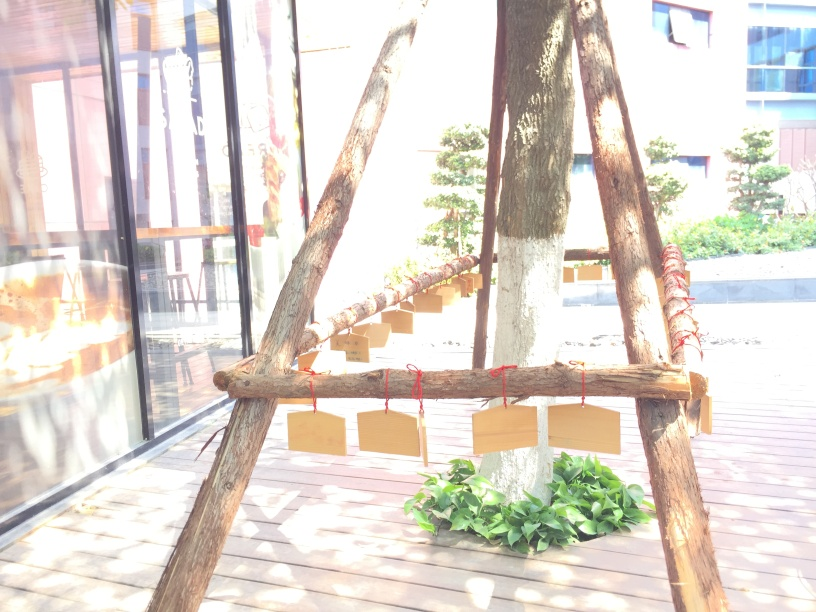Are there any quality issues with this image? The primary quality issue with this image is overexposure, resulting in a loss of detail in the brighter areas. There's also a lack of focus on the subject, which could be intended as an artistic choice but makes it difficult to discern finer details of the objects in the image. 